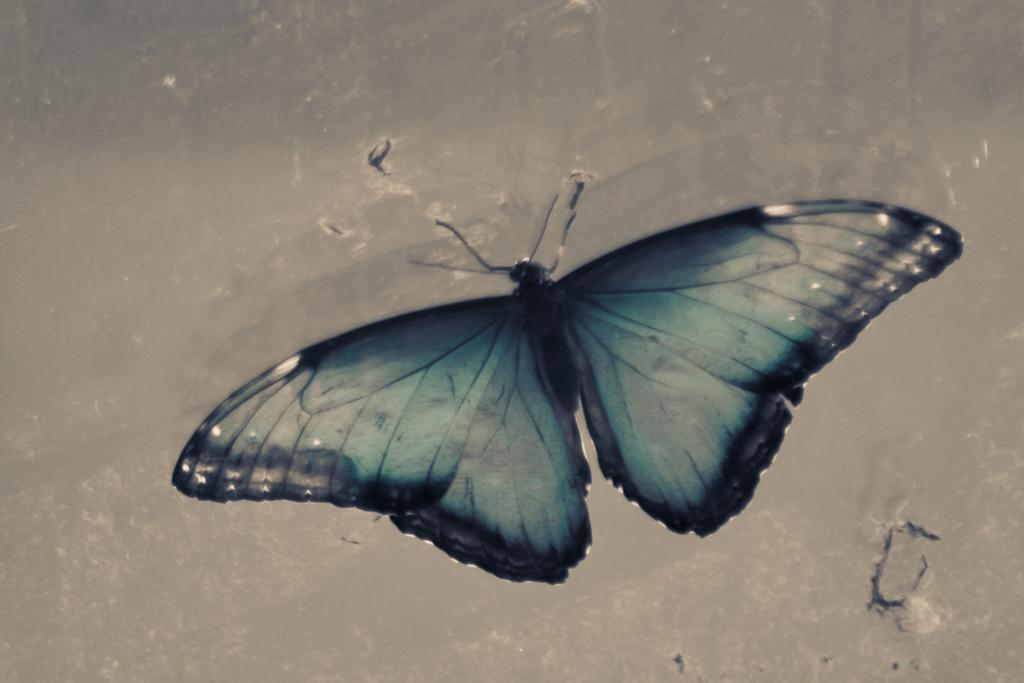What is the main subject in the middle of the image? There is a butterfly in the middle of the image. What can be seen in the background of the image? There is a wall in the background of the image. How many sisters are holding a needle in the image? There are no sisters or needles present in the image; it features a butterfly and a wall in the background. 